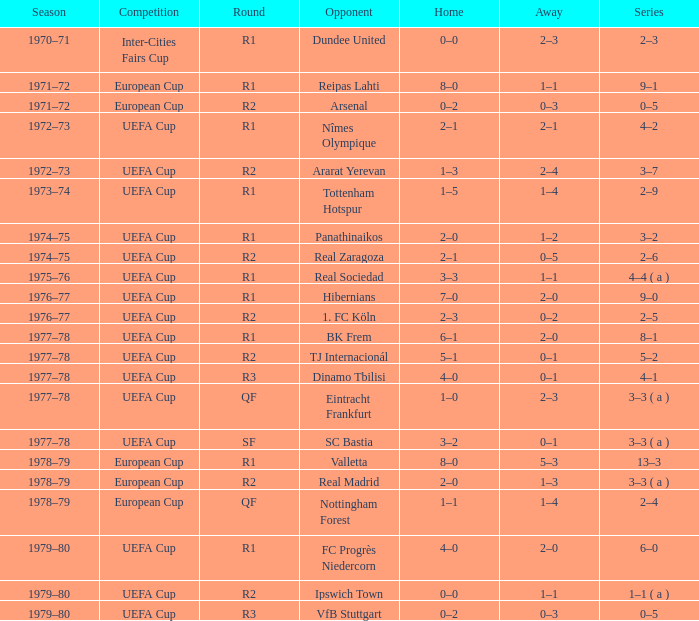Parse the full table. {'header': ['Season', 'Competition', 'Round', 'Opponent', 'Home', 'Away', 'Series'], 'rows': [['1970–71', 'Inter-Cities Fairs Cup', 'R1', 'Dundee United', '0–0', '2–3', '2–3'], ['1971–72', 'European Cup', 'R1', 'Reipas Lahti', '8–0', '1–1', '9–1'], ['1971–72', 'European Cup', 'R2', 'Arsenal', '0–2', '0–3', '0–5'], ['1972–73', 'UEFA Cup', 'R1', 'Nîmes Olympique', '2–1', '2–1', '4–2'], ['1972–73', 'UEFA Cup', 'R2', 'Ararat Yerevan', '1–3', '2–4', '3–7'], ['1973–74', 'UEFA Cup', 'R1', 'Tottenham Hotspur', '1–5', '1–4', '2–9'], ['1974–75', 'UEFA Cup', 'R1', 'Panathinaikos', '2–0', '1–2', '3–2'], ['1974–75', 'UEFA Cup', 'R2', 'Real Zaragoza', '2–1', '0–5', '2–6'], ['1975–76', 'UEFA Cup', 'R1', 'Real Sociedad', '3–3', '1–1', '4–4 ( a )'], ['1976–77', 'UEFA Cup', 'R1', 'Hibernians', '7–0', '2–0', '9–0'], ['1976–77', 'UEFA Cup', 'R2', '1. FC Köln', '2–3', '0–2', '2–5'], ['1977–78', 'UEFA Cup', 'R1', 'BK Frem', '6–1', '2–0', '8–1'], ['1977–78', 'UEFA Cup', 'R2', 'TJ Internacionál', '5–1', '0–1', '5–2'], ['1977–78', 'UEFA Cup', 'R3', 'Dinamo Tbilisi', '4–0', '0–1', '4–1'], ['1977–78', 'UEFA Cup', 'QF', 'Eintracht Frankfurt', '1–0', '2–3', '3–3 ( a )'], ['1977–78', 'UEFA Cup', 'SF', 'SC Bastia', '3–2', '0–1', '3–3 ( a )'], ['1978–79', 'European Cup', 'R1', 'Valletta', '8–0', '5–3', '13–3'], ['1978–79', 'European Cup', 'R2', 'Real Madrid', '2–0', '1–3', '3–3 ( a )'], ['1978–79', 'European Cup', 'QF', 'Nottingham Forest', '1–1', '1–4', '2–4'], ['1979–80', 'UEFA Cup', 'R1', 'FC Progrès Niedercorn', '4–0', '2–0', '6–0'], ['1979–80', 'UEFA Cup', 'R2', 'Ipswich Town', '0–0', '1–1', '1–1 ( a )'], ['1979–80', 'UEFA Cup', 'R3', 'VfB Stuttgart', '0–2', '0–3', '0–5']]} Which Opponent has an Away of 1–1, and a Home of 3–3? Real Sociedad. 